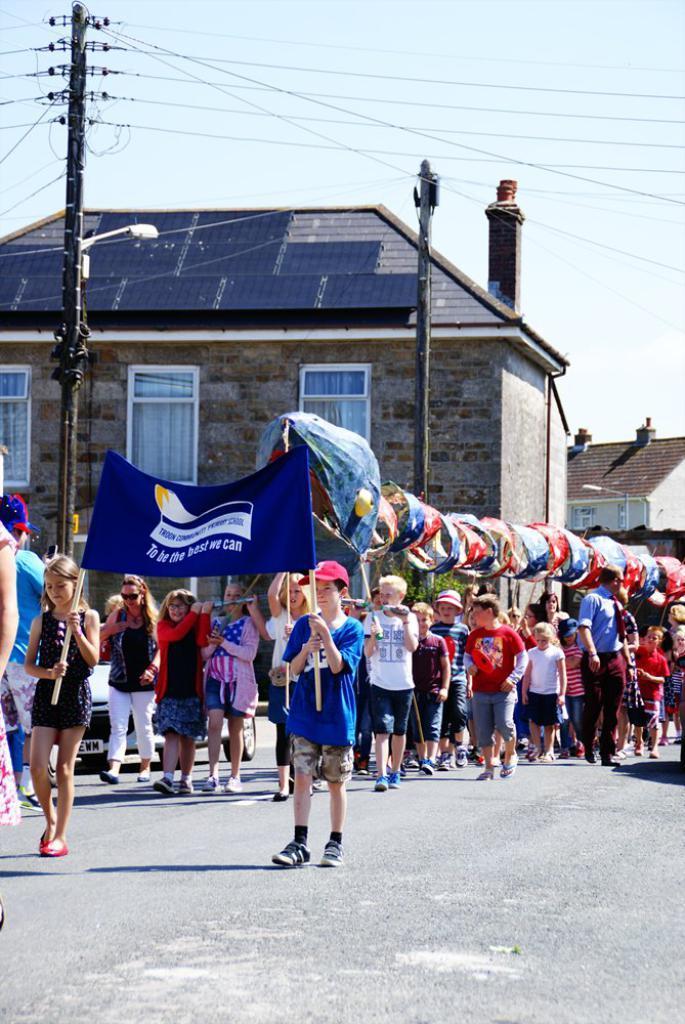How would you summarize this image in a sentence or two? In the foreground I can see a crowd on the road are holding a snake made with cloth in hand and posters. In the background I can see houses, windows, poles and wires. On the top I can see the sky. This image is taken during a sunny day. 